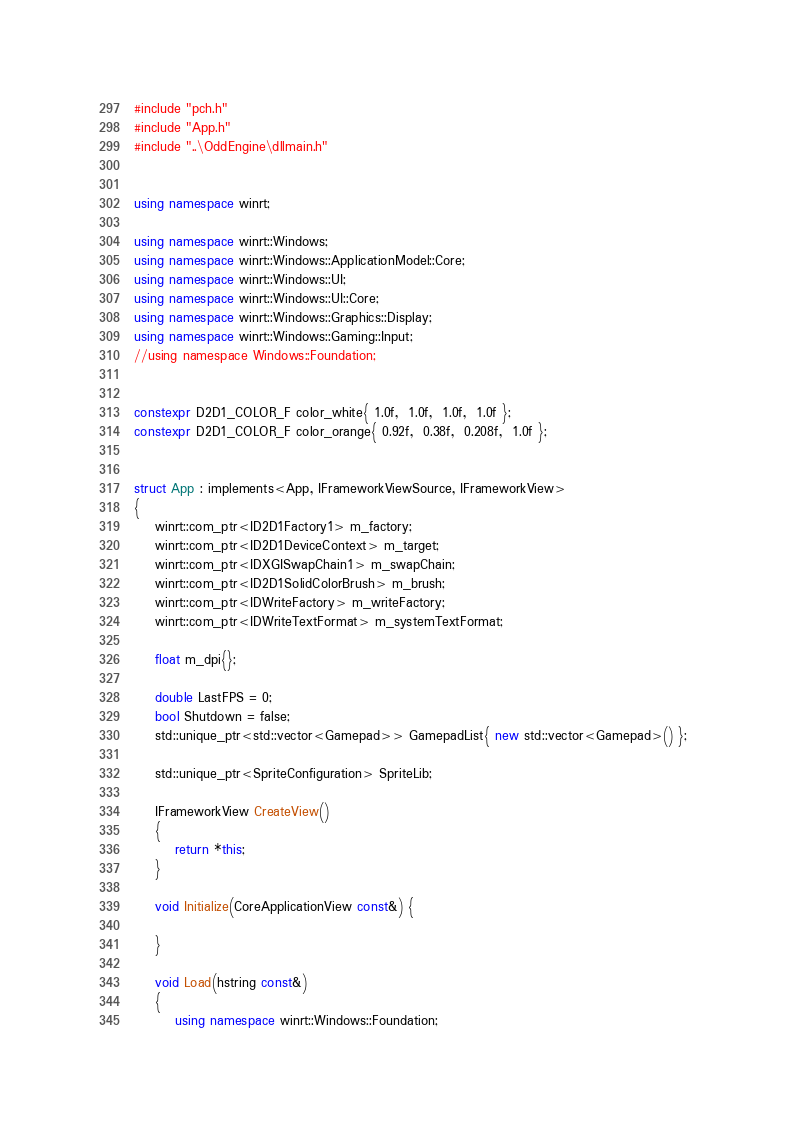<code> <loc_0><loc_0><loc_500><loc_500><_C++_>#include "pch.h"
#include "App.h"
#include "..\OddEngine\dllmain.h"


using namespace winrt;

using namespace winrt::Windows;
using namespace winrt::Windows::ApplicationModel::Core;
using namespace winrt::Windows::UI;
using namespace winrt::Windows::UI::Core;
using namespace winrt::Windows::Graphics::Display;
using namespace winrt::Windows::Gaming::Input;
//using namespace Windows::Foundation;


constexpr D2D1_COLOR_F color_white{ 1.0f,  1.0f,  1.0f,  1.0f };
constexpr D2D1_COLOR_F color_orange{ 0.92f,  0.38f,  0.208f,  1.0f };


struct App : implements<App, IFrameworkViewSource, IFrameworkView>
{
	winrt::com_ptr<ID2D1Factory1> m_factory;
	winrt::com_ptr<ID2D1DeviceContext> m_target;
	winrt::com_ptr<IDXGISwapChain1> m_swapChain;
	winrt::com_ptr<ID2D1SolidColorBrush> m_brush;
	winrt::com_ptr<IDWriteFactory> m_writeFactory;
	winrt::com_ptr<IDWriteTextFormat> m_systemTextFormat;
	
	float m_dpi{};

	double LastFPS = 0;
	bool Shutdown = false;
	std::unique_ptr<std::vector<Gamepad>> GamepadList{ new std::vector<Gamepad>() };

	std::unique_ptr<SpriteConfiguration> SpriteLib;

	IFrameworkView CreateView()
	{
		return *this;
	}

	void Initialize(CoreApplicationView const&) {

	}

	void Load(hstring const&)
	{
		using namespace winrt::Windows::Foundation;
</code> 